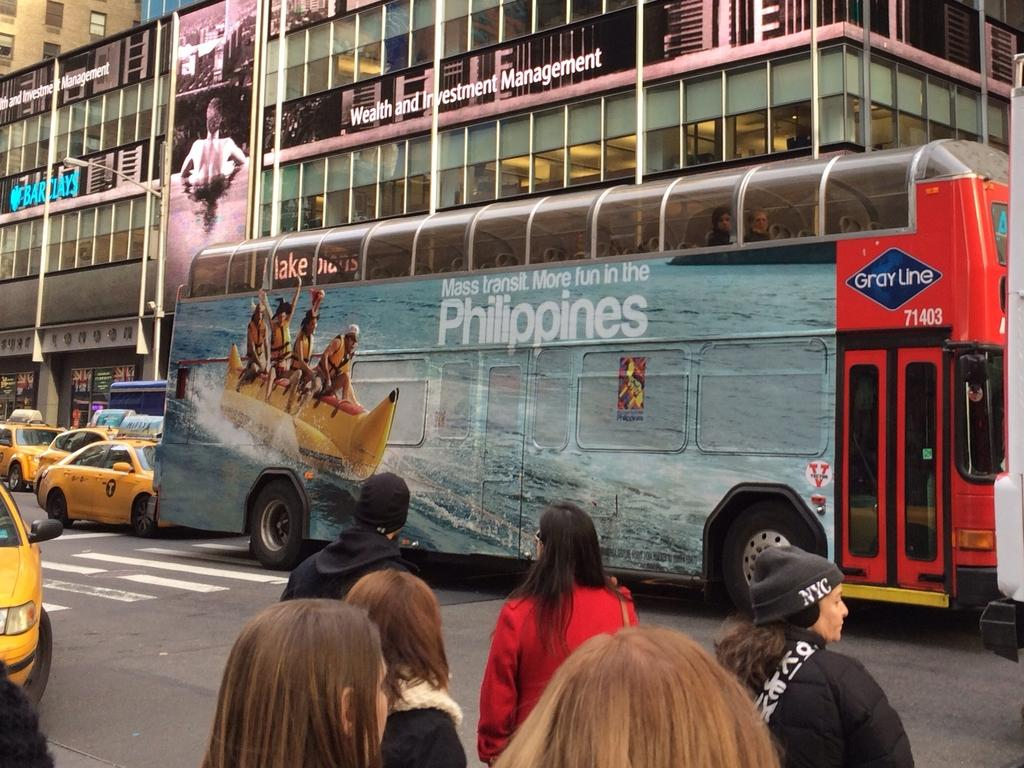<image>
Give a short and clear explanation of the subsequent image. A large red bus is covered with an add for the Philippines. 